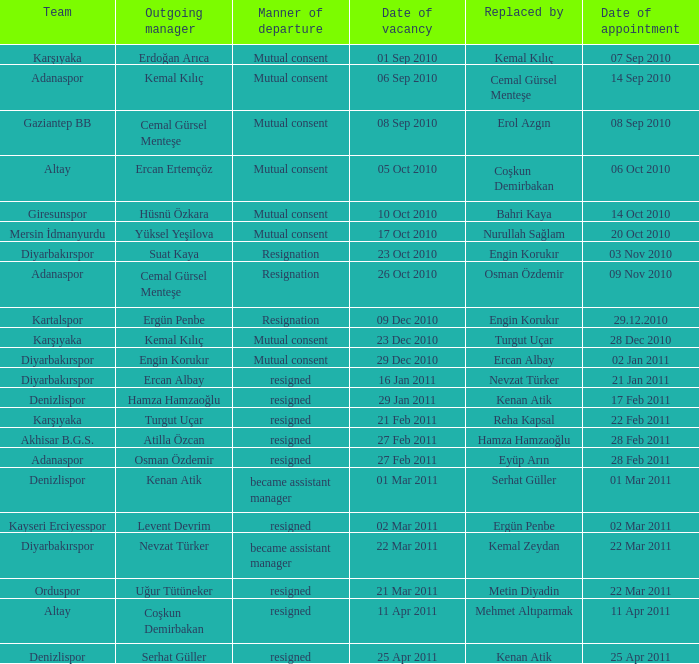Who replaced the manager of Akhisar B.G.S.? Hamza Hamzaoğlu. 